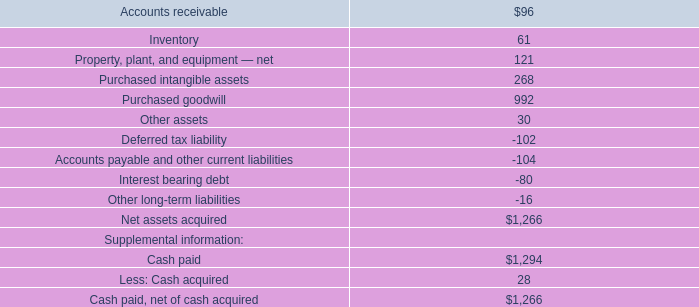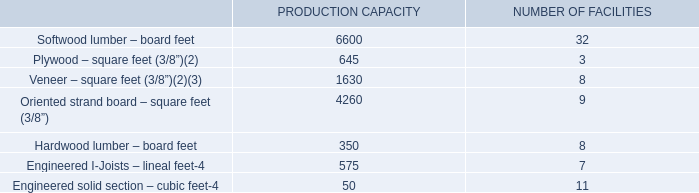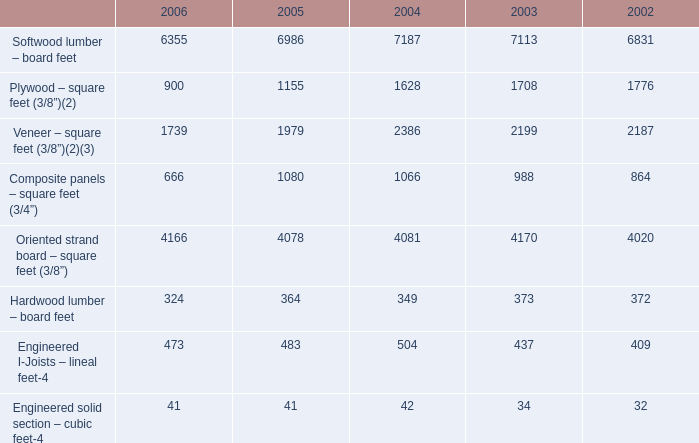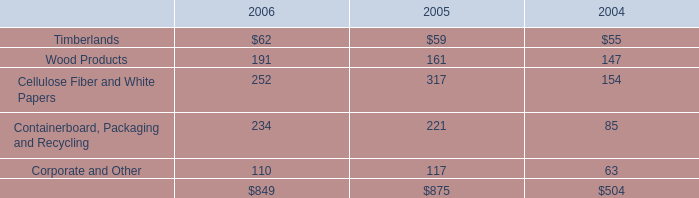What is the sum of the Oriented strand board – square feet (3/8”) in the sections where Softwood lumber – board feet is positive? 
Computations: (4260 + 9)
Answer: 4269.0. 